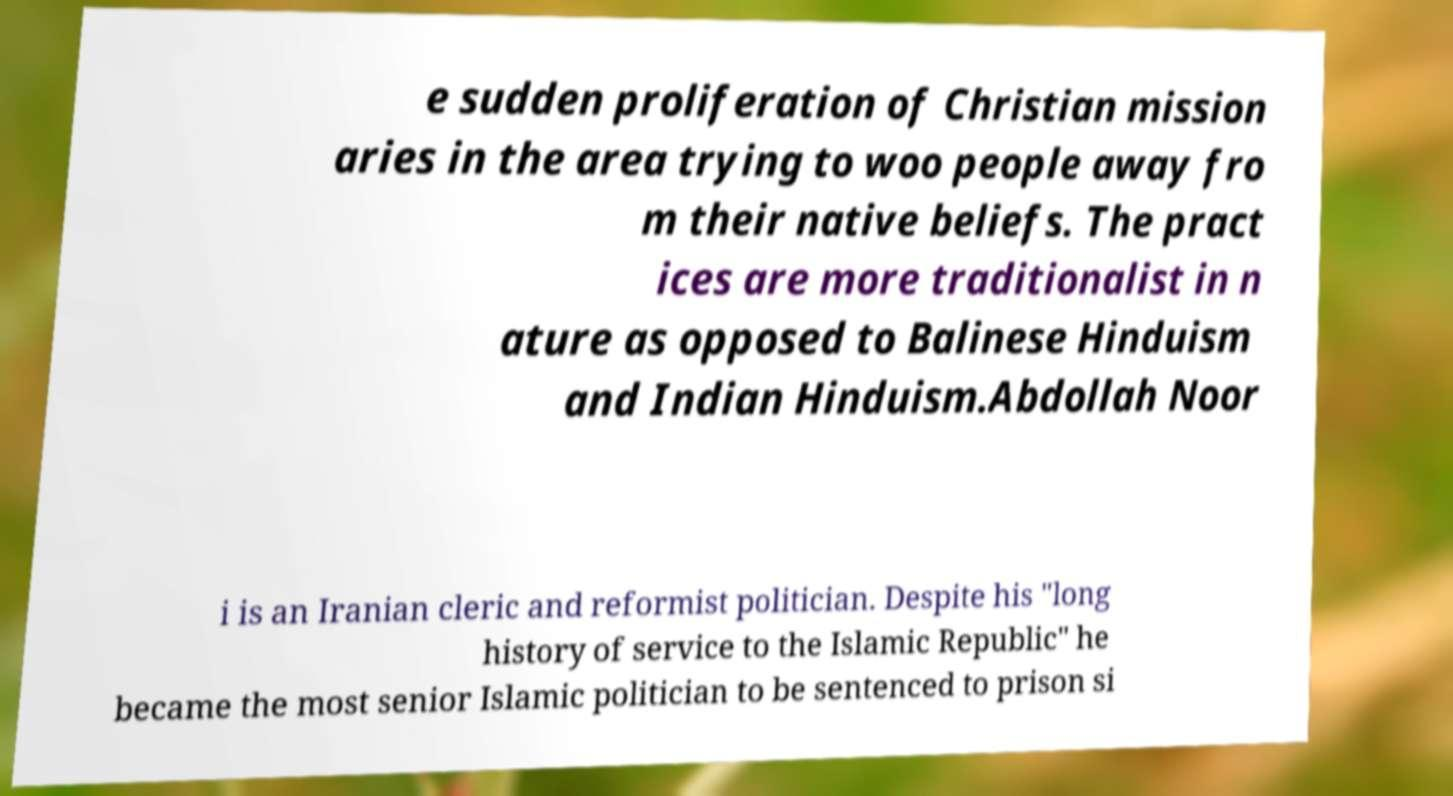I need the written content from this picture converted into text. Can you do that? e sudden proliferation of Christian mission aries in the area trying to woo people away fro m their native beliefs. The pract ices are more traditionalist in n ature as opposed to Balinese Hinduism and Indian Hinduism.Abdollah Noor i is an Iranian cleric and reformist politician. Despite his "long history of service to the Islamic Republic" he became the most senior Islamic politician to be sentenced to prison si 